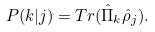Convert formula to latex. <formula><loc_0><loc_0><loc_500><loc_500>P ( k | j ) = T r ( \hat { \Pi } _ { k } \hat { \rho } _ { j } ) .</formula> 